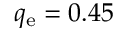Convert formula to latex. <formula><loc_0><loc_0><loc_500><loc_500>q _ { e } = 0 . 4 5</formula> 